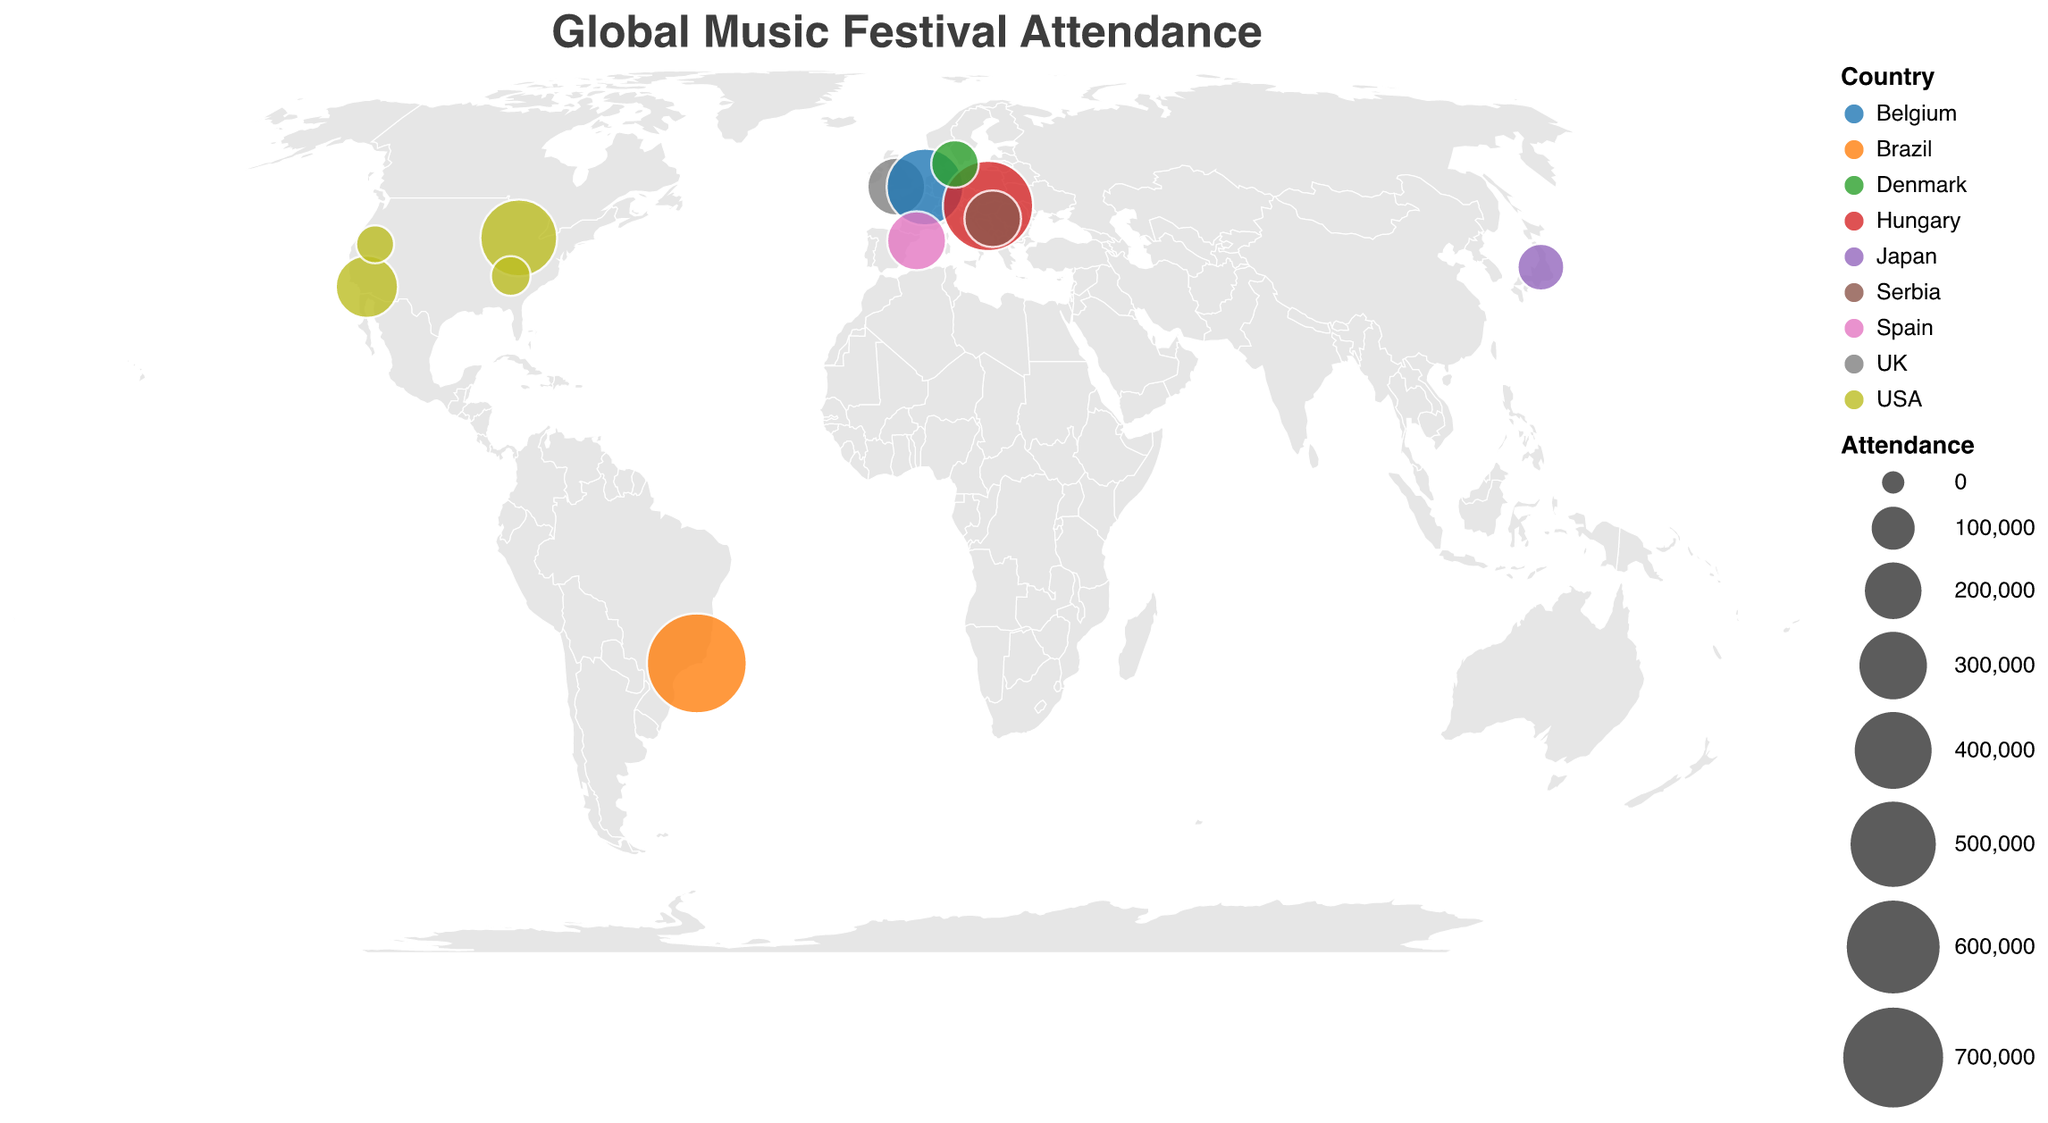How many music festivals are represented on the map? Count the number of circles on the plot.
Answer: 12 Which festival has the highest attendance? Look for the largest circle on the map, then check the tooltip for its attendance.
Answer: Rock in Rio Which country hosts the most music festivals in this dataset? Look at the colors representing countries and count the number of festivals for each country.
Answer: USA What is the total attendance for music festivals in the USA? Sum the attendance numbers for all festivals located in the USA (Coachella, Lollapalooza, Bonnaroo, Burning Man). The attendance values are 250,000, 400,000, 80,000, and 70,000 respectively. Total = 250,000 + 400,000 + 80,000 + 70,000.
Answer: 800,000 Which festival is located closest to the equator? Check the latitude values and find the one closest to 0.
Answer: Rock in Rio Compare the attendance of Roskilde and Fuji Rock. Which one has higher attendance? Find the circles representing Roskilde and Fuji Rock on the map, then check their attendance in the tooltip. Roskilde: 130,000, Fuji Rock: 125,000.
Answer: Roskilde What is the average attendance of the European festivals in the dataset? Identify festivals in Europe (Glastonbury, Tomorrowland, Sziget, Roskilde, Exit, Primavera Sound), sum their attendance values (210,000 + 400,000 + 565,000 + 130,000 + 200,000 + 220,000), and divide by the number of festivals (6). Total = 1,725,000. Average = 1,725,000 / 6.
Answer: 287,500 Which festival is located at the highest latitude? Find the festival with the highest positive latitude value.
Answer: Roskilde How does Sziget compare to Lollapalooza in terms of attendance size? Compare the circle sizes of Sziget and Lollapalooza on the map and check the tooltips for their attendance values. Sziget: 565,000, Lollapalooza: 400,000.
Answer: Sziget has a higher attendance Which festival in the dataset is the farthest west in terms of longitude? Identify the festival with the most negative longitude value.
Answer: Burning Man 